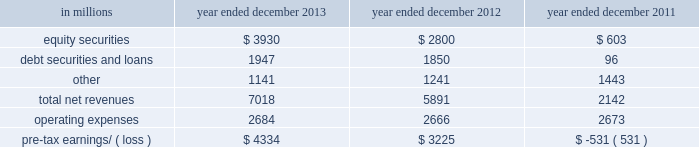Management 2019s discussion and analysis net revenues in equities were $ 8.21 billion for 2012 , essentially unchanged compared with 2011 .
Net revenues in securities services were significantly higher compared with 2011 , reflecting a gain of $ 494 million on the sale of our hedge fund administration business .
In addition , equities client execution net revenues were higher than 2011 , primarily reflecting significantly higher results in cash products , principally due to increased levels of client activity .
These increases were offset by lower commissions and fees , reflecting declines in the united states , europe and asia .
Our average daily volumes during 2012 were lower in each of these regions compared with 2011 , consistent with listed cash equity market volumes .
During 2012 , equities operated in an environment generally characterized by an increase in global equity prices and lower volatility levels .
The net loss attributable to the impact of changes in our own credit spreads on borrowings for which the fair value option was elected was $ 714 million ( $ 433 million and $ 281 million related to fixed income , currency and commodities client execution and equities client execution , respectively ) for 2012 , compared with a net gain of $ 596 million ( $ 399 million and $ 197 million related to fixed income , currency and commodities client execution and equities client execution , respectively ) for 2011 .
During 2012 , institutional client services operated in an environment generally characterized by continued broad market concerns and uncertainties , although positive developments helped to improve market conditions .
These developments included certain central bank actions to ease monetary policy and address funding risks for european financial institutions .
In addition , the u.s .
Economy posted stable to improving economic data , including favorable developments in unemployment and housing .
These improvements resulted in tighter credit spreads , higher global equity prices and lower levels of volatility .
However , concerns about the outlook for the global economy and continued political uncertainty , particularly the political debate in the united states surrounding the fiscal cliff , generally resulted in client risk aversion and lower activity levels .
Also , uncertainty over financial regulatory reform persisted .
Operating expenses were $ 12.48 billion for 2012 , 3% ( 3 % ) lower than 2011 , primarily due to lower brokerage , clearing , exchange and distribution fees , and lower impairment charges , partially offset by higher net provisions for litigation and regulatory proceedings .
Pre- tax earnings were $ 5.64 billion in 2012 , 27% ( 27 % ) higher than 2011 .
Investing & lending investing & lending includes our investing activities and the origination of loans to provide financing to clients .
These investments , some of which are consolidated , and loans are typically longer-term in nature .
We make investments , directly and indirectly through funds that we manage , in debt securities and loans , public and private equity securities , and real estate entities .
The table below presents the operating results of our investing & lending segment. .
2013 versus 2012 .
Net revenues in investing & lending were $ 7.02 billion for 2013 , 19% ( 19 % ) higher than 2012 , reflecting a significant increase in net gains from investments in equity securities , driven by company-specific events and stronger corporate performance , as well as significantly higher global equity prices .
In addition , net gains and net interest income from debt securities and loans were slightly higher , while other net revenues , related to our consolidated investments , were lower compared with 2012 .
If equity markets decline or credit spreads widen , net revenues in investing & lending would likely be negatively impacted .
Operating expenses were $ 2.68 billion for 2013 , essentially unchanged compared with 2012 .
Operating expenses during 2013 included lower impairment charges and lower operating expenses related to consolidated investments , partially offset by increased compensation and benefits expenses due to higher net revenues compared with 2012 .
Pre-tax earnings were $ 4.33 billion in 2013 , 34% ( 34 % ) higher than 2012 .
52 goldman sachs 2013 annual report .
Pre-tax earnings were $ 4.33 billion in 2013 , what were they in billions in 2012? 
Computations: (4.33 * (1 - (34 / 100)))
Answer: 2.8578. 